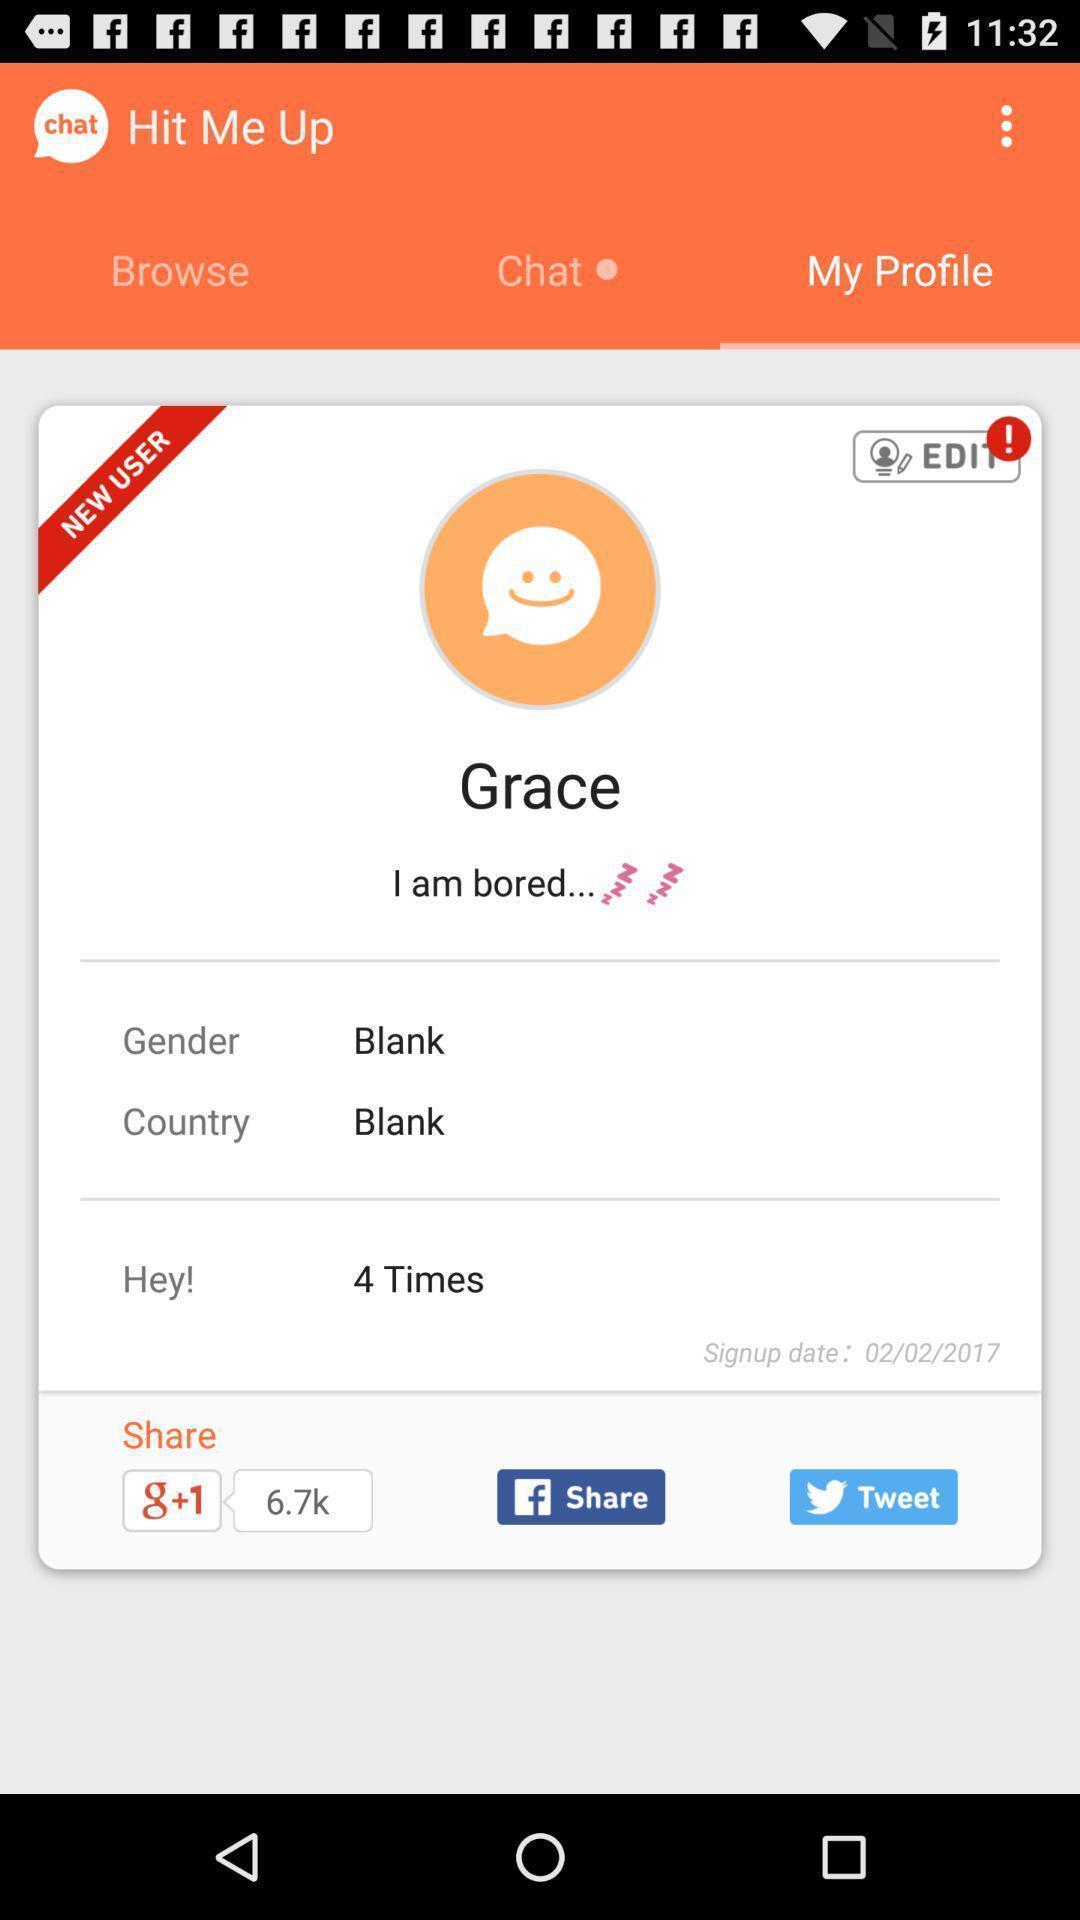What is the overall content of this screenshot? Profile page of a social page. 